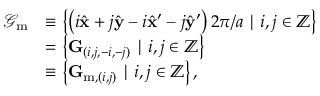Convert formula to latex. <formula><loc_0><loc_0><loc_500><loc_500>\begin{array} { r l } { \mathcal { G } _ { m } } & { \equiv \left \{ \left ( { i } \hat { x } + { j } \hat { y } - { i } \hat { x } ^ { \prime } - { j } \hat { y } ^ { \prime } \right ) 2 \pi / a | { i } , { j } \in \mathbb { Z } \right \} } \\ & { = \left \{ G _ { ( i , j , - i , - j ) } | i , j \in \mathbb { Z } \right \} } \\ & { \equiv \left \{ G _ { m , ( i , j ) } | i , j \in \mathbb { Z } \right \} , } \end{array}</formula> 